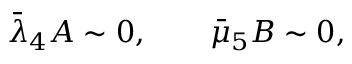<formula> <loc_0><loc_0><loc_500><loc_500>\begin{array} { r } { \bar { \lambda } _ { 4 } A \sim 0 , \quad \bar { \mu } _ { 5 } B \sim 0 , } \end{array}</formula> 